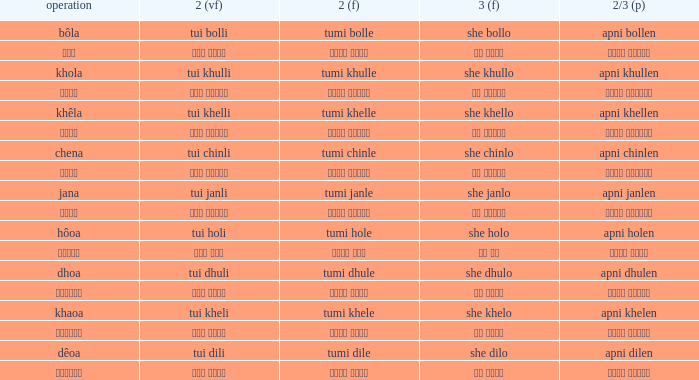What is the 3rd for the 2nd Tui Dhuli? She dhulo. 